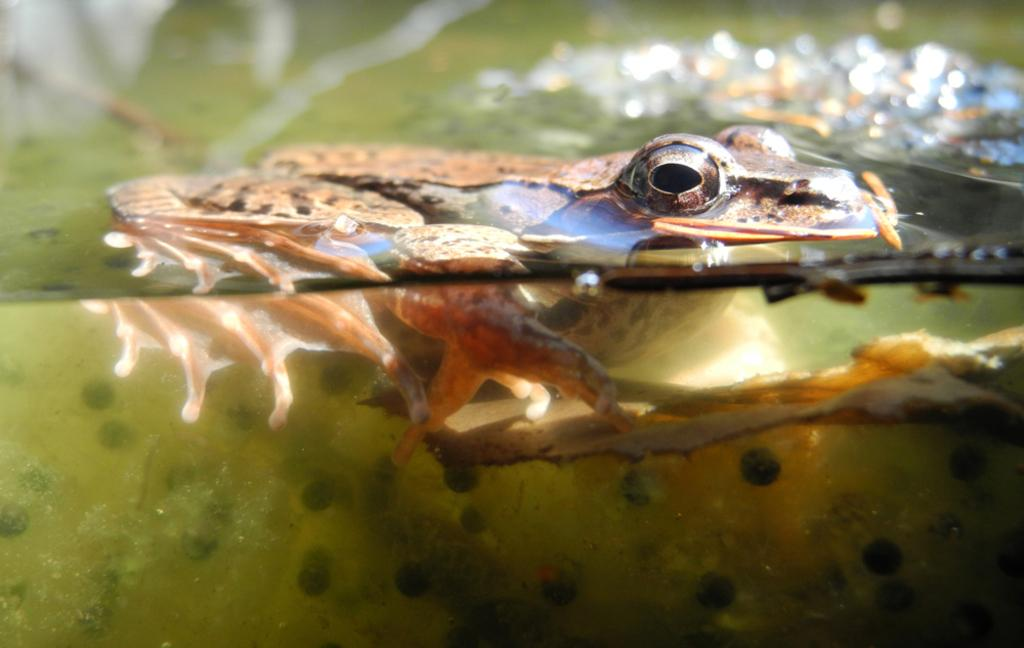What animal is present in the image? There is a frog in the image. Where is the frog located? The frog is in the water. How much of the frog's body is above the water surface? Only half of the frog's body is above the water surface. What type of cherries are growing on the stem in the image? There are no cherries or stems present in the image; it features a frog in the water. 